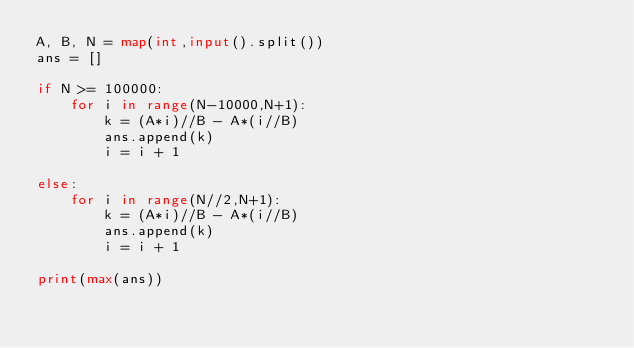Convert code to text. <code><loc_0><loc_0><loc_500><loc_500><_Python_>A, B, N = map(int,input().split())
ans = []

if N >= 100000:
    for i in range(N-10000,N+1): 
        k = (A*i)//B - A*(i//B)
        ans.append(k)
        i = i + 1
    
else:
    for i in range(N//2,N+1):
        k = (A*i)//B - A*(i//B)
        ans.append(k)
        i = i + 1
    
print(max(ans))</code> 